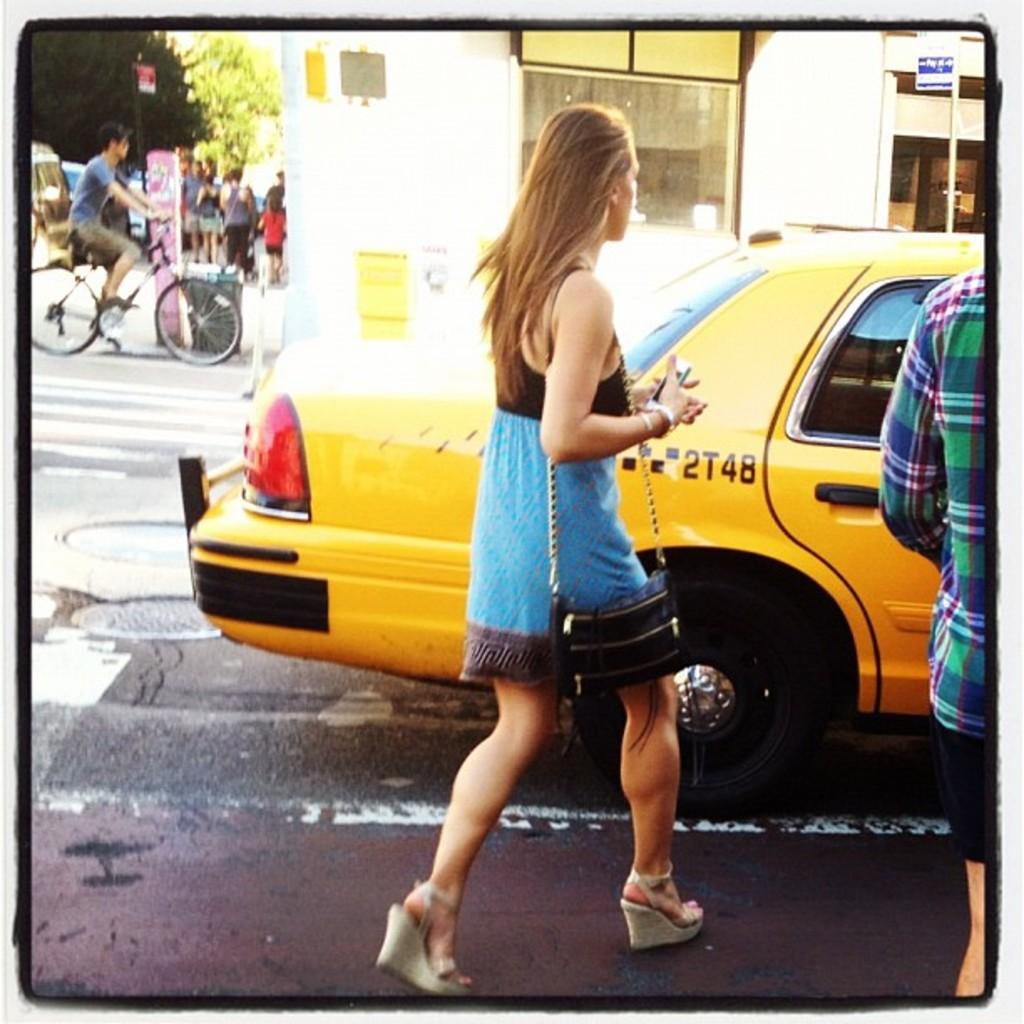<image>
Give a short and clear explanation of the subsequent image. A yellow cab has the identification number 2T48 on its side. 